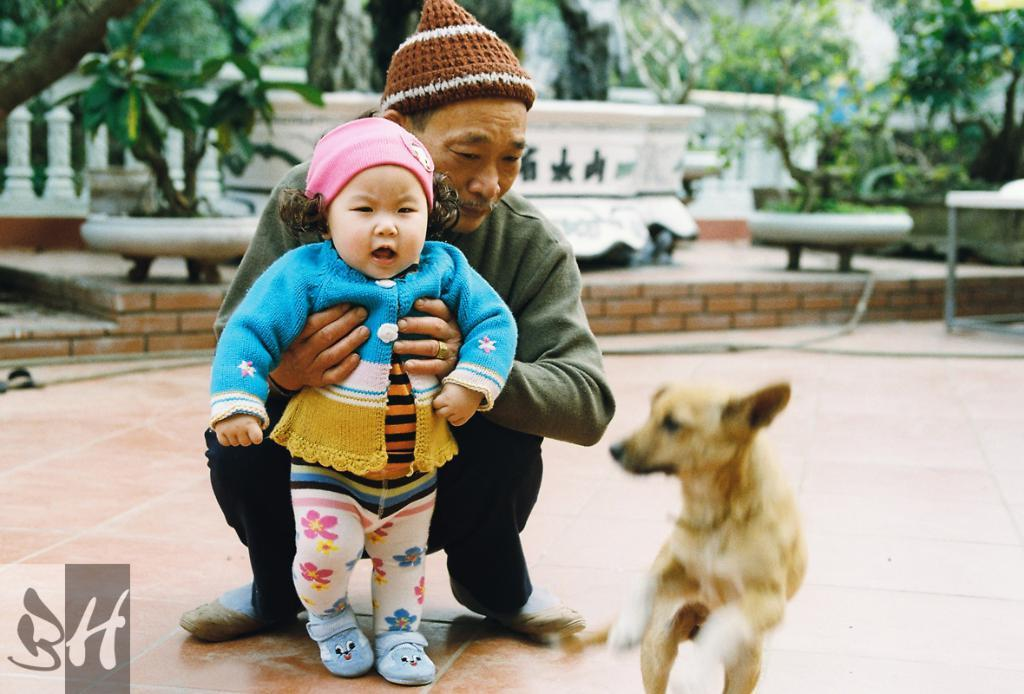What type of animal can be seen in the picture? There is a dog in the picture. Who is the other person in the picture? There is an old man in the picture. What is the old man doing in the picture? The old man is holding a baby. How is the old man holding the baby? The old man is using both hands to hold the baby. What type of clothing is the old man wearing? The old man is wearing a monkey cap. What can be seen in the background of the picture? There are trees, a balcony, and the sky visible in the background of the picture. What type of furniture can be seen in the park in the image? There is no park or furniture present in the image. In what year was the image taken? The provided facts do not include information about the year the image was taken. 